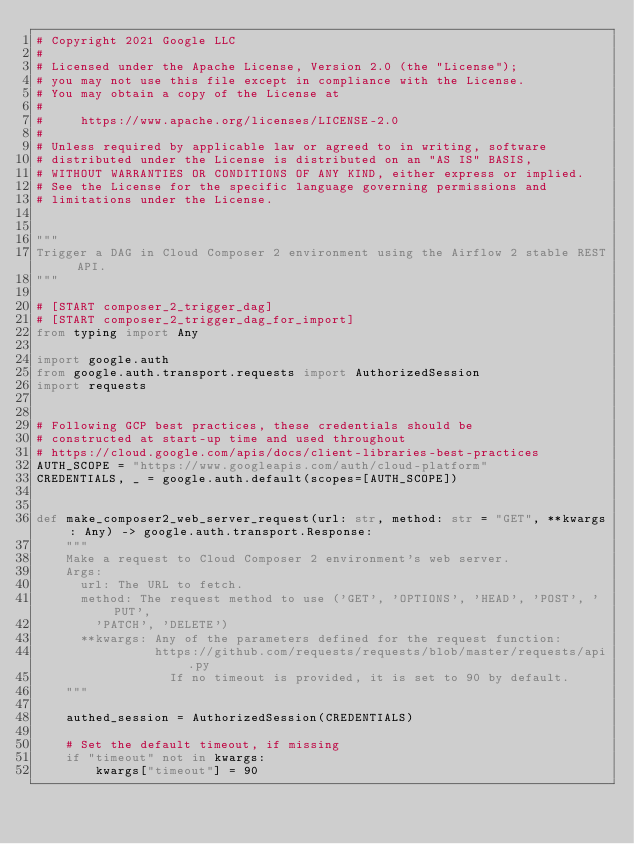Convert code to text. <code><loc_0><loc_0><loc_500><loc_500><_Python_># Copyright 2021 Google LLC
#
# Licensed under the Apache License, Version 2.0 (the "License");
# you may not use this file except in compliance with the License.
# You may obtain a copy of the License at
#
#     https://www.apache.org/licenses/LICENSE-2.0
#
# Unless required by applicable law or agreed to in writing, software
# distributed under the License is distributed on an "AS IS" BASIS,
# WITHOUT WARRANTIES OR CONDITIONS OF ANY KIND, either express or implied.
# See the License for the specific language governing permissions and
# limitations under the License.


"""
Trigger a DAG in Cloud Composer 2 environment using the Airflow 2 stable REST API.
"""

# [START composer_2_trigger_dag]
# [START composer_2_trigger_dag_for_import]
from typing import Any

import google.auth
from google.auth.transport.requests import AuthorizedSession
import requests


# Following GCP best practices, these credentials should be
# constructed at start-up time and used throughout
# https://cloud.google.com/apis/docs/client-libraries-best-practices
AUTH_SCOPE = "https://www.googleapis.com/auth/cloud-platform"
CREDENTIALS, _ = google.auth.default(scopes=[AUTH_SCOPE])


def make_composer2_web_server_request(url: str, method: str = "GET", **kwargs: Any) -> google.auth.transport.Response:
    """
    Make a request to Cloud Composer 2 environment's web server.
    Args:
      url: The URL to fetch.
      method: The request method to use ('GET', 'OPTIONS', 'HEAD', 'POST', 'PUT',
        'PATCH', 'DELETE')
      **kwargs: Any of the parameters defined for the request function:
                https://github.com/requests/requests/blob/master/requests/api.py
                  If no timeout is provided, it is set to 90 by default.
    """

    authed_session = AuthorizedSession(CREDENTIALS)

    # Set the default timeout, if missing
    if "timeout" not in kwargs:
        kwargs["timeout"] = 90
</code> 